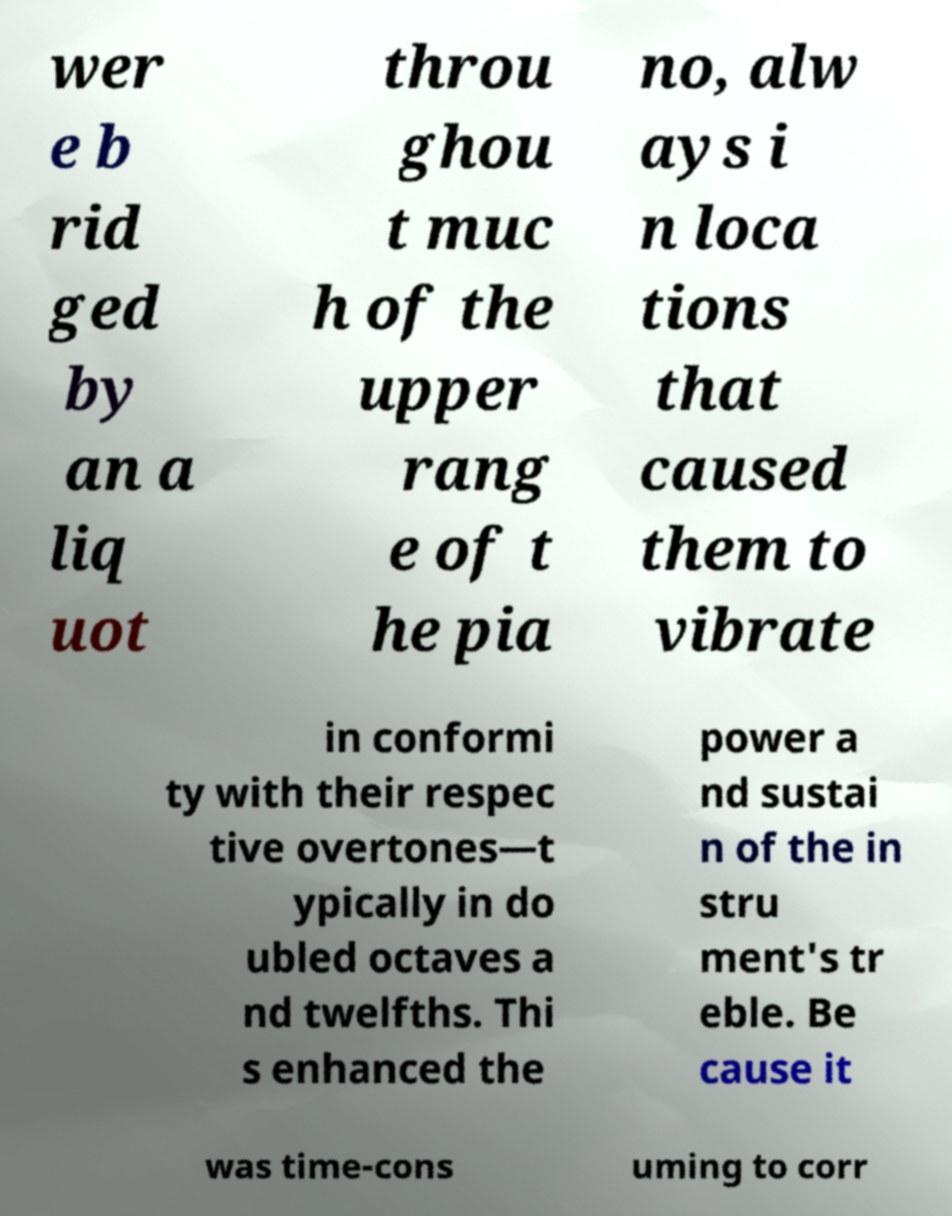I need the written content from this picture converted into text. Can you do that? wer e b rid ged by an a liq uot throu ghou t muc h of the upper rang e of t he pia no, alw ays i n loca tions that caused them to vibrate in conformi ty with their respec tive overtones—t ypically in do ubled octaves a nd twelfths. Thi s enhanced the power a nd sustai n of the in stru ment's tr eble. Be cause it was time-cons uming to corr 